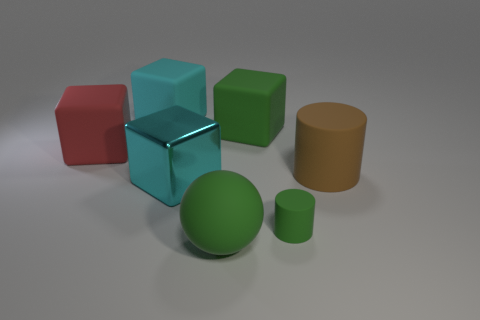Are there any other objects of the same size as the cyan shiny object?
Your response must be concise. Yes. What material is the sphere that is the same size as the brown object?
Your response must be concise. Rubber. What is the size of the matte cube that is behind the big green rubber object that is behind the big red cube?
Your response must be concise. Large. There is a thing in front of the green rubber cylinder; does it have the same size as the small green cylinder?
Ensure brevity in your answer.  No. Is the number of large green rubber spheres in front of the big green cube greater than the number of green cylinders behind the large red rubber thing?
Ensure brevity in your answer.  Yes. What shape is the object that is right of the large green cube and in front of the brown matte cylinder?
Offer a very short reply. Cylinder. There is a big green rubber object that is to the right of the rubber sphere; what shape is it?
Keep it short and to the point. Cube. How big is the cyan object that is behind the matte thing that is left of the cyan object that is behind the big brown thing?
Make the answer very short. Large. Is the shape of the red thing the same as the big brown thing?
Ensure brevity in your answer.  No. There is a matte object that is both behind the large rubber cylinder and right of the green rubber ball; what is its size?
Offer a terse response. Large. 